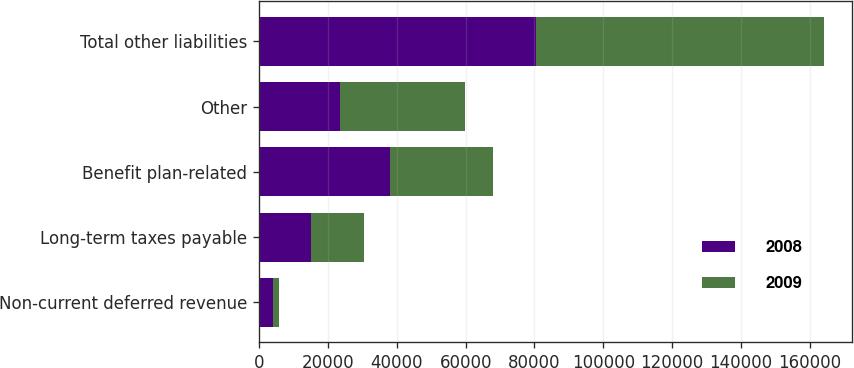Convert chart. <chart><loc_0><loc_0><loc_500><loc_500><stacked_bar_chart><ecel><fcel>Non-current deferred revenue<fcel>Long-term taxes payable<fcel>Benefit plan-related<fcel>Other<fcel>Total other liabilities<nl><fcel>2008<fcel>3912<fcel>15064<fcel>37977<fcel>23618<fcel>80571<nl><fcel>2009<fcel>1913<fcel>15386<fcel>30098<fcel>36075<fcel>83472<nl></chart> 